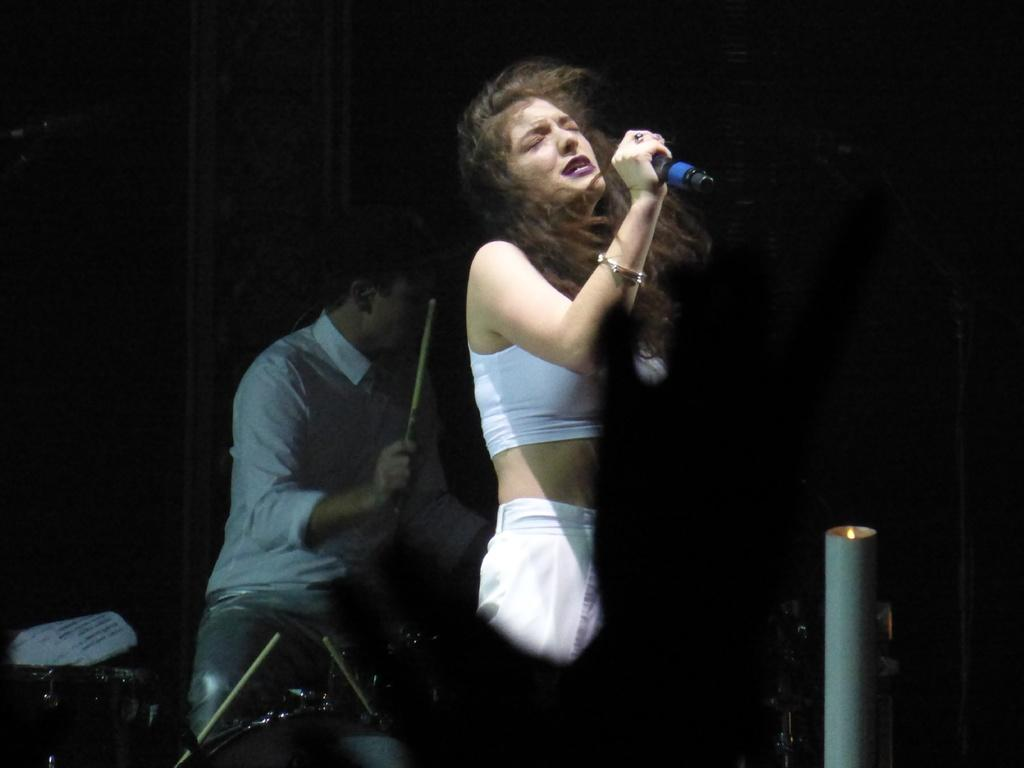What is the woman in the image doing? The woman is holding a microphone and singing. What is the man in the image doing? The man is playing musical instruments. What object is the woman holding while singing? The woman is holding a microphone. What type of fruit is the woman using to sing in the image? There is no fruit present in the image, and the woman is using a microphone to sing. 